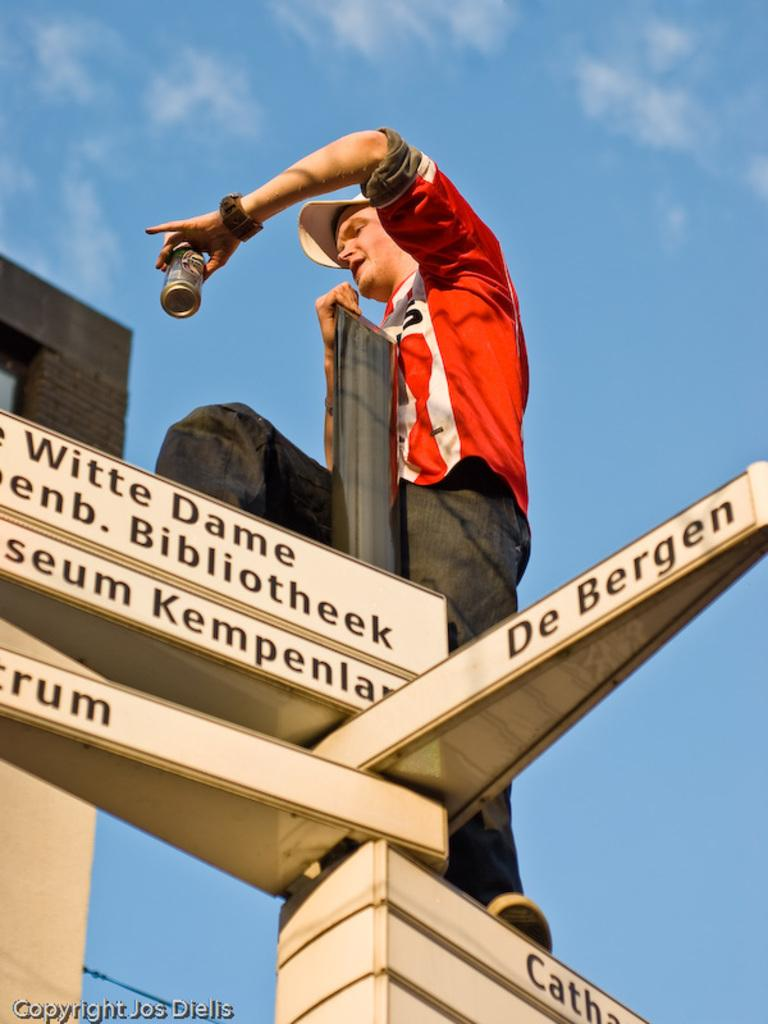What is the main subject of the image? There is a person in the image. What is the person holding in the image? The person is holding a can. Where is the person standing in the image? The person is standing on a pole. What is attached to the pole? There are boards on the pole. What can be seen on the left side of the image? There is text on the left side of the image. What is the color of the sky in the image? The sky is blue in color. Can you see any birds flying over the ocean in the image? There is no ocean or birds present in the image; it features a red car with a person standing next to it and a building in the background. 